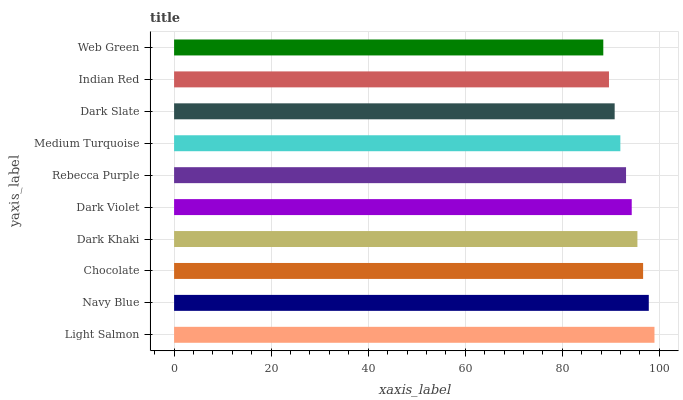Is Web Green the minimum?
Answer yes or no. Yes. Is Light Salmon the maximum?
Answer yes or no. Yes. Is Navy Blue the minimum?
Answer yes or no. No. Is Navy Blue the maximum?
Answer yes or no. No. Is Light Salmon greater than Navy Blue?
Answer yes or no. Yes. Is Navy Blue less than Light Salmon?
Answer yes or no. Yes. Is Navy Blue greater than Light Salmon?
Answer yes or no. No. Is Light Salmon less than Navy Blue?
Answer yes or no. No. Is Dark Violet the high median?
Answer yes or no. Yes. Is Rebecca Purple the low median?
Answer yes or no. Yes. Is Indian Red the high median?
Answer yes or no. No. Is Web Green the low median?
Answer yes or no. No. 